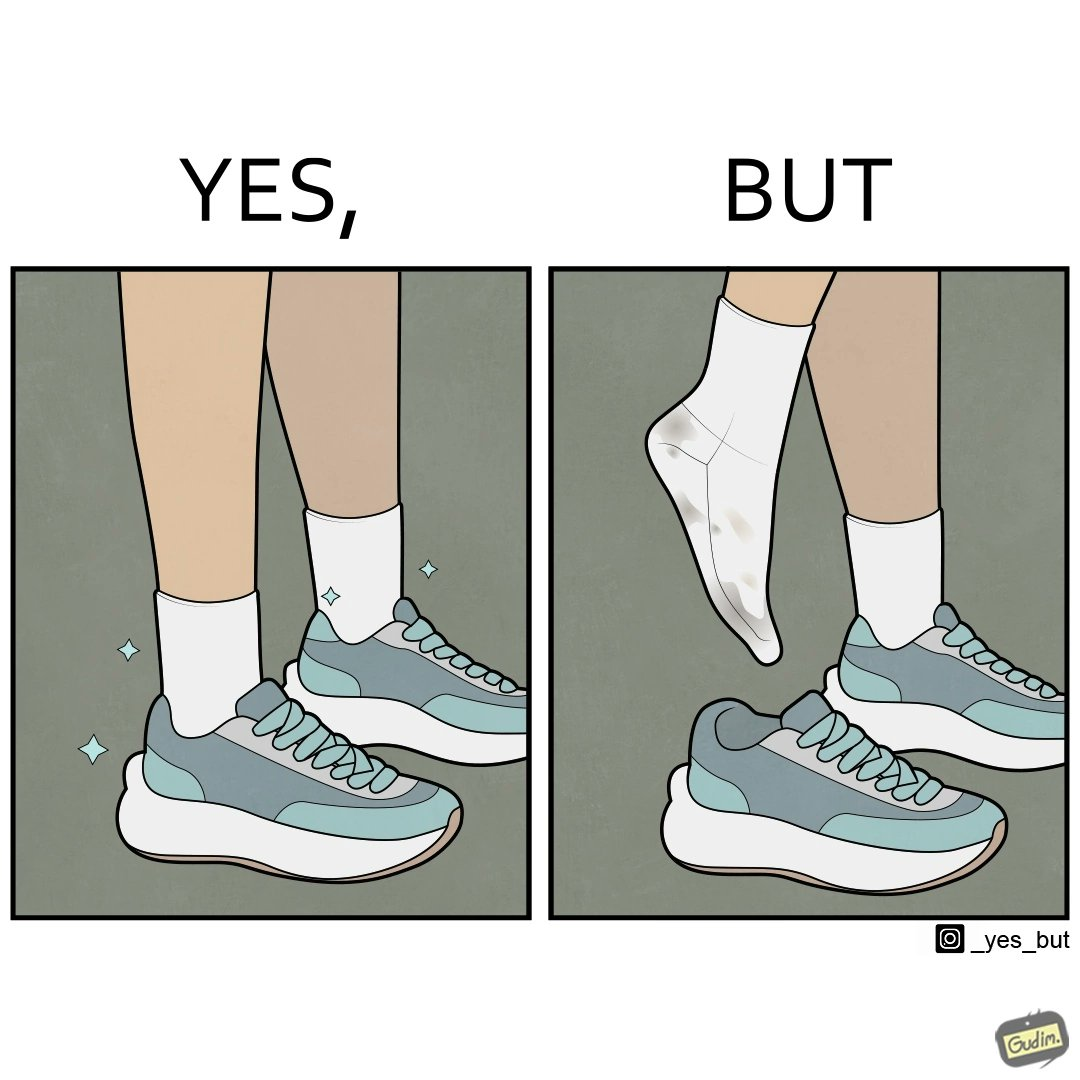Describe the satirical element in this image. The person's shocks is very dirty although the shoes are very clean. Thus there is an irony that not all things are same as they appear. 